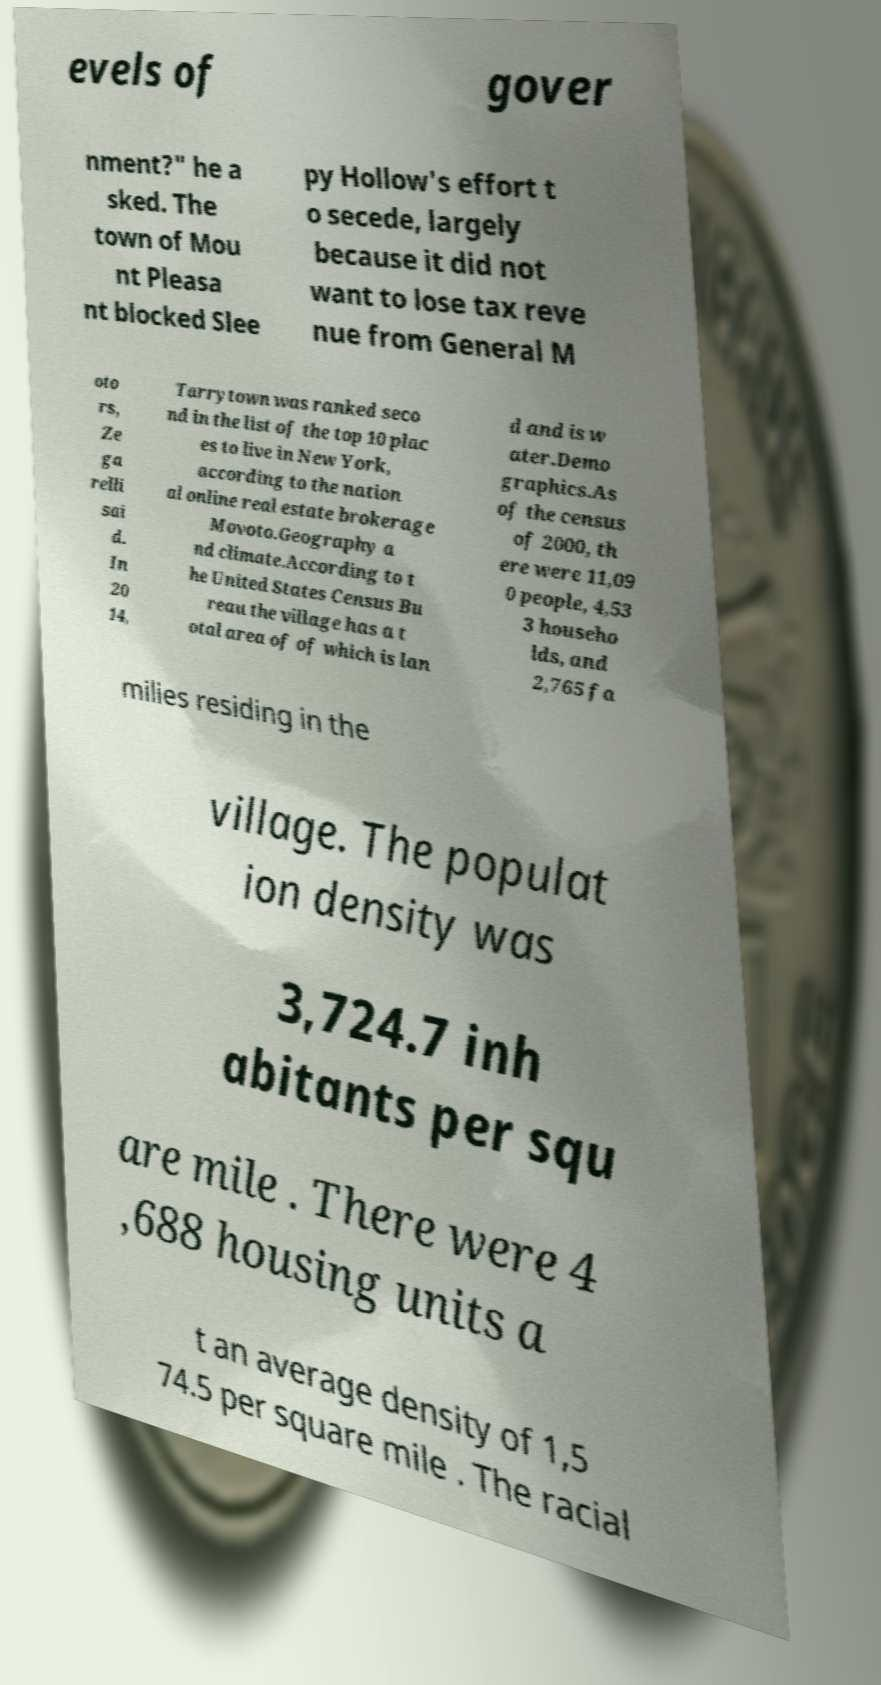For documentation purposes, I need the text within this image transcribed. Could you provide that? evels of gover nment?" he a sked. The town of Mou nt Pleasa nt blocked Slee py Hollow's effort t o secede, largely because it did not want to lose tax reve nue from General M oto rs, Ze ga relli sai d. In 20 14, Tarrytown was ranked seco nd in the list of the top 10 plac es to live in New York, according to the nation al online real estate brokerage Movoto.Geography a nd climate.According to t he United States Census Bu reau the village has a t otal area of of which is lan d and is w ater.Demo graphics.As of the census of 2000, th ere were 11,09 0 people, 4,53 3 househo lds, and 2,765 fa milies residing in the village. The populat ion density was 3,724.7 inh abitants per squ are mile . There were 4 ,688 housing units a t an average density of 1,5 74.5 per square mile . The racial 